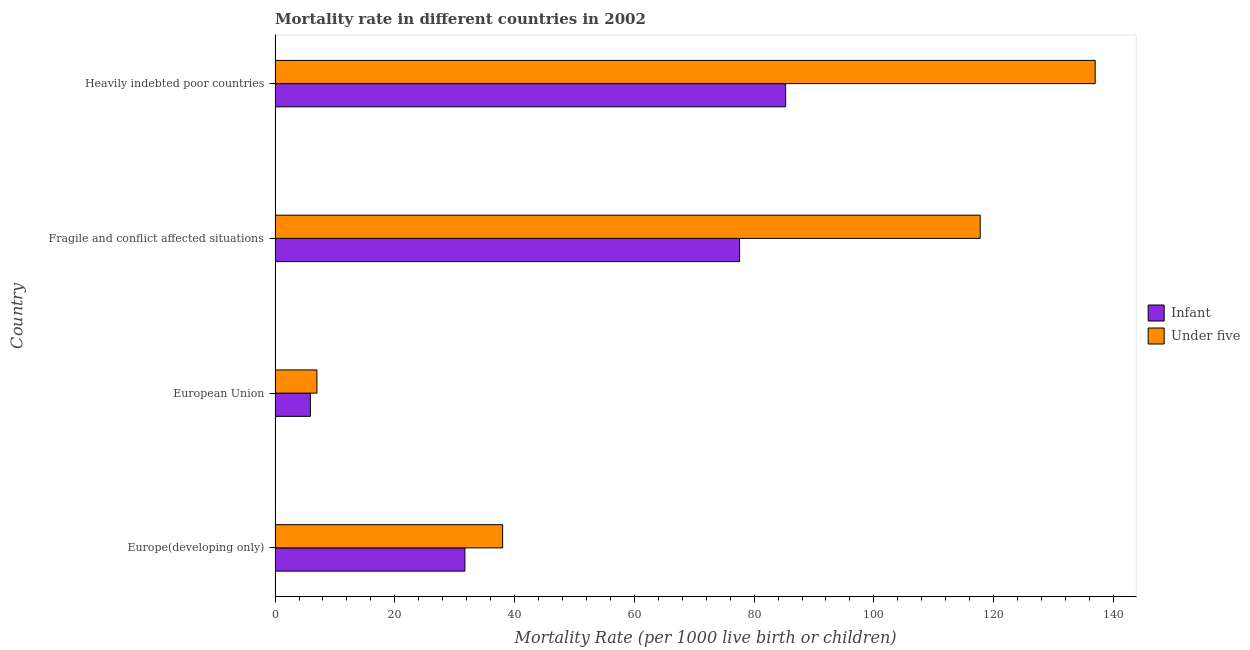Are the number of bars on each tick of the Y-axis equal?
Offer a very short reply. Yes. How many bars are there on the 2nd tick from the top?
Your answer should be compact. 2. What is the label of the 4th group of bars from the top?
Provide a succinct answer. Europe(developing only). What is the infant mortality rate in Europe(developing only)?
Ensure brevity in your answer.  31.7. Across all countries, what is the maximum infant mortality rate?
Your answer should be compact. 85.26. Across all countries, what is the minimum infant mortality rate?
Offer a very short reply. 5.9. In which country was the under-5 mortality rate maximum?
Your answer should be very brief. Heavily indebted poor countries. What is the total under-5 mortality rate in the graph?
Keep it short and to the point. 299.69. What is the difference between the under-5 mortality rate in Fragile and conflict affected situations and that in Heavily indebted poor countries?
Provide a short and direct response. -19.2. What is the difference between the under-5 mortality rate in Heavily indebted poor countries and the infant mortality rate in European Union?
Provide a short and direct response. 131.05. What is the average infant mortality rate per country?
Ensure brevity in your answer.  50.11. What is the difference between the under-5 mortality rate and infant mortality rate in Heavily indebted poor countries?
Your response must be concise. 51.69. What is the ratio of the under-5 mortality rate in Fragile and conflict affected situations to that in Heavily indebted poor countries?
Provide a short and direct response. 0.86. Is the under-5 mortality rate in Europe(developing only) less than that in Fragile and conflict affected situations?
Offer a very short reply. Yes. What is the difference between the highest and the lowest infant mortality rate?
Your answer should be compact. 79.36. In how many countries, is the infant mortality rate greater than the average infant mortality rate taken over all countries?
Make the answer very short. 2. Is the sum of the infant mortality rate in European Union and Fragile and conflict affected situations greater than the maximum under-5 mortality rate across all countries?
Provide a succinct answer. No. What does the 2nd bar from the top in Europe(developing only) represents?
Offer a terse response. Infant. What does the 1st bar from the bottom in Fragile and conflict affected situations represents?
Your answer should be compact. Infant. How many bars are there?
Your response must be concise. 8. Are the values on the major ticks of X-axis written in scientific E-notation?
Offer a very short reply. No. Does the graph contain any zero values?
Provide a short and direct response. No. Does the graph contain grids?
Give a very brief answer. No. Where does the legend appear in the graph?
Give a very brief answer. Center right. What is the title of the graph?
Your answer should be very brief. Mortality rate in different countries in 2002. Does "Malaria" appear as one of the legend labels in the graph?
Give a very brief answer. No. What is the label or title of the X-axis?
Keep it short and to the point. Mortality Rate (per 1000 live birth or children). What is the label or title of the Y-axis?
Provide a succinct answer. Country. What is the Mortality Rate (per 1000 live birth or children) of Infant in Europe(developing only)?
Your answer should be compact. 31.7. What is the Mortality Rate (per 1000 live birth or children) in Under five in Europe(developing only)?
Your answer should be very brief. 38. What is the Mortality Rate (per 1000 live birth or children) of Infant in European Union?
Make the answer very short. 5.9. What is the Mortality Rate (per 1000 live birth or children) of Under five in European Union?
Offer a terse response. 6.98. What is the Mortality Rate (per 1000 live birth or children) of Infant in Fragile and conflict affected situations?
Offer a terse response. 77.58. What is the Mortality Rate (per 1000 live birth or children) in Under five in Fragile and conflict affected situations?
Offer a very short reply. 117.75. What is the Mortality Rate (per 1000 live birth or children) in Infant in Heavily indebted poor countries?
Give a very brief answer. 85.26. What is the Mortality Rate (per 1000 live birth or children) in Under five in Heavily indebted poor countries?
Your answer should be very brief. 136.95. Across all countries, what is the maximum Mortality Rate (per 1000 live birth or children) of Infant?
Keep it short and to the point. 85.26. Across all countries, what is the maximum Mortality Rate (per 1000 live birth or children) in Under five?
Offer a very short reply. 136.95. Across all countries, what is the minimum Mortality Rate (per 1000 live birth or children) of Infant?
Provide a succinct answer. 5.9. Across all countries, what is the minimum Mortality Rate (per 1000 live birth or children) of Under five?
Keep it short and to the point. 6.98. What is the total Mortality Rate (per 1000 live birth or children) of Infant in the graph?
Offer a very short reply. 200.44. What is the total Mortality Rate (per 1000 live birth or children) of Under five in the graph?
Offer a very short reply. 299.69. What is the difference between the Mortality Rate (per 1000 live birth or children) of Infant in Europe(developing only) and that in European Union?
Offer a very short reply. 25.8. What is the difference between the Mortality Rate (per 1000 live birth or children) in Under five in Europe(developing only) and that in European Union?
Your answer should be compact. 31.02. What is the difference between the Mortality Rate (per 1000 live birth or children) of Infant in Europe(developing only) and that in Fragile and conflict affected situations?
Give a very brief answer. -45.88. What is the difference between the Mortality Rate (per 1000 live birth or children) in Under five in Europe(developing only) and that in Fragile and conflict affected situations?
Offer a terse response. -79.75. What is the difference between the Mortality Rate (per 1000 live birth or children) in Infant in Europe(developing only) and that in Heavily indebted poor countries?
Your answer should be very brief. -53.56. What is the difference between the Mortality Rate (per 1000 live birth or children) of Under five in Europe(developing only) and that in Heavily indebted poor countries?
Make the answer very short. -98.95. What is the difference between the Mortality Rate (per 1000 live birth or children) in Infant in European Union and that in Fragile and conflict affected situations?
Make the answer very short. -71.68. What is the difference between the Mortality Rate (per 1000 live birth or children) of Under five in European Union and that in Fragile and conflict affected situations?
Provide a short and direct response. -110.77. What is the difference between the Mortality Rate (per 1000 live birth or children) in Infant in European Union and that in Heavily indebted poor countries?
Your answer should be compact. -79.36. What is the difference between the Mortality Rate (per 1000 live birth or children) of Under five in European Union and that in Heavily indebted poor countries?
Your response must be concise. -129.97. What is the difference between the Mortality Rate (per 1000 live birth or children) in Infant in Fragile and conflict affected situations and that in Heavily indebted poor countries?
Offer a very short reply. -7.69. What is the difference between the Mortality Rate (per 1000 live birth or children) in Under five in Fragile and conflict affected situations and that in Heavily indebted poor countries?
Your answer should be compact. -19.2. What is the difference between the Mortality Rate (per 1000 live birth or children) in Infant in Europe(developing only) and the Mortality Rate (per 1000 live birth or children) in Under five in European Union?
Provide a succinct answer. 24.72. What is the difference between the Mortality Rate (per 1000 live birth or children) of Infant in Europe(developing only) and the Mortality Rate (per 1000 live birth or children) of Under five in Fragile and conflict affected situations?
Give a very brief answer. -86.05. What is the difference between the Mortality Rate (per 1000 live birth or children) in Infant in Europe(developing only) and the Mortality Rate (per 1000 live birth or children) in Under five in Heavily indebted poor countries?
Your answer should be compact. -105.25. What is the difference between the Mortality Rate (per 1000 live birth or children) of Infant in European Union and the Mortality Rate (per 1000 live birth or children) of Under five in Fragile and conflict affected situations?
Make the answer very short. -111.85. What is the difference between the Mortality Rate (per 1000 live birth or children) in Infant in European Union and the Mortality Rate (per 1000 live birth or children) in Under five in Heavily indebted poor countries?
Offer a very short reply. -131.05. What is the difference between the Mortality Rate (per 1000 live birth or children) in Infant in Fragile and conflict affected situations and the Mortality Rate (per 1000 live birth or children) in Under five in Heavily indebted poor countries?
Provide a succinct answer. -59.38. What is the average Mortality Rate (per 1000 live birth or children) in Infant per country?
Provide a succinct answer. 50.11. What is the average Mortality Rate (per 1000 live birth or children) of Under five per country?
Your response must be concise. 74.92. What is the difference between the Mortality Rate (per 1000 live birth or children) of Infant and Mortality Rate (per 1000 live birth or children) of Under five in European Union?
Provide a succinct answer. -1.08. What is the difference between the Mortality Rate (per 1000 live birth or children) of Infant and Mortality Rate (per 1000 live birth or children) of Under five in Fragile and conflict affected situations?
Provide a succinct answer. -40.18. What is the difference between the Mortality Rate (per 1000 live birth or children) of Infant and Mortality Rate (per 1000 live birth or children) of Under five in Heavily indebted poor countries?
Make the answer very short. -51.69. What is the ratio of the Mortality Rate (per 1000 live birth or children) of Infant in Europe(developing only) to that in European Union?
Offer a very short reply. 5.37. What is the ratio of the Mortality Rate (per 1000 live birth or children) of Under five in Europe(developing only) to that in European Union?
Make the answer very short. 5.44. What is the ratio of the Mortality Rate (per 1000 live birth or children) of Infant in Europe(developing only) to that in Fragile and conflict affected situations?
Ensure brevity in your answer.  0.41. What is the ratio of the Mortality Rate (per 1000 live birth or children) in Under five in Europe(developing only) to that in Fragile and conflict affected situations?
Ensure brevity in your answer.  0.32. What is the ratio of the Mortality Rate (per 1000 live birth or children) in Infant in Europe(developing only) to that in Heavily indebted poor countries?
Offer a terse response. 0.37. What is the ratio of the Mortality Rate (per 1000 live birth or children) in Under five in Europe(developing only) to that in Heavily indebted poor countries?
Offer a terse response. 0.28. What is the ratio of the Mortality Rate (per 1000 live birth or children) of Infant in European Union to that in Fragile and conflict affected situations?
Your answer should be very brief. 0.08. What is the ratio of the Mortality Rate (per 1000 live birth or children) in Under five in European Union to that in Fragile and conflict affected situations?
Your answer should be very brief. 0.06. What is the ratio of the Mortality Rate (per 1000 live birth or children) of Infant in European Union to that in Heavily indebted poor countries?
Provide a short and direct response. 0.07. What is the ratio of the Mortality Rate (per 1000 live birth or children) in Under five in European Union to that in Heavily indebted poor countries?
Offer a terse response. 0.05. What is the ratio of the Mortality Rate (per 1000 live birth or children) in Infant in Fragile and conflict affected situations to that in Heavily indebted poor countries?
Your answer should be very brief. 0.91. What is the ratio of the Mortality Rate (per 1000 live birth or children) of Under five in Fragile and conflict affected situations to that in Heavily indebted poor countries?
Ensure brevity in your answer.  0.86. What is the difference between the highest and the second highest Mortality Rate (per 1000 live birth or children) in Infant?
Provide a short and direct response. 7.69. What is the difference between the highest and the second highest Mortality Rate (per 1000 live birth or children) in Under five?
Your response must be concise. 19.2. What is the difference between the highest and the lowest Mortality Rate (per 1000 live birth or children) in Infant?
Make the answer very short. 79.36. What is the difference between the highest and the lowest Mortality Rate (per 1000 live birth or children) of Under five?
Provide a short and direct response. 129.97. 